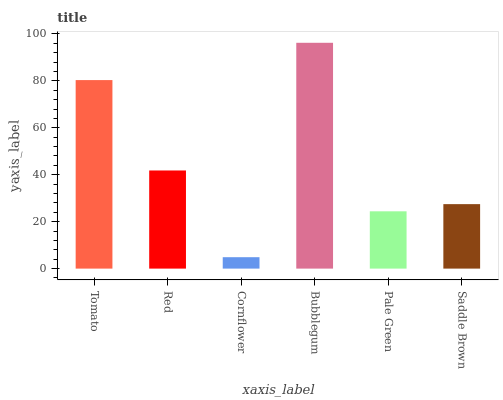Is Red the minimum?
Answer yes or no. No. Is Red the maximum?
Answer yes or no. No. Is Tomato greater than Red?
Answer yes or no. Yes. Is Red less than Tomato?
Answer yes or no. Yes. Is Red greater than Tomato?
Answer yes or no. No. Is Tomato less than Red?
Answer yes or no. No. Is Red the high median?
Answer yes or no. Yes. Is Saddle Brown the low median?
Answer yes or no. Yes. Is Saddle Brown the high median?
Answer yes or no. No. Is Tomato the low median?
Answer yes or no. No. 